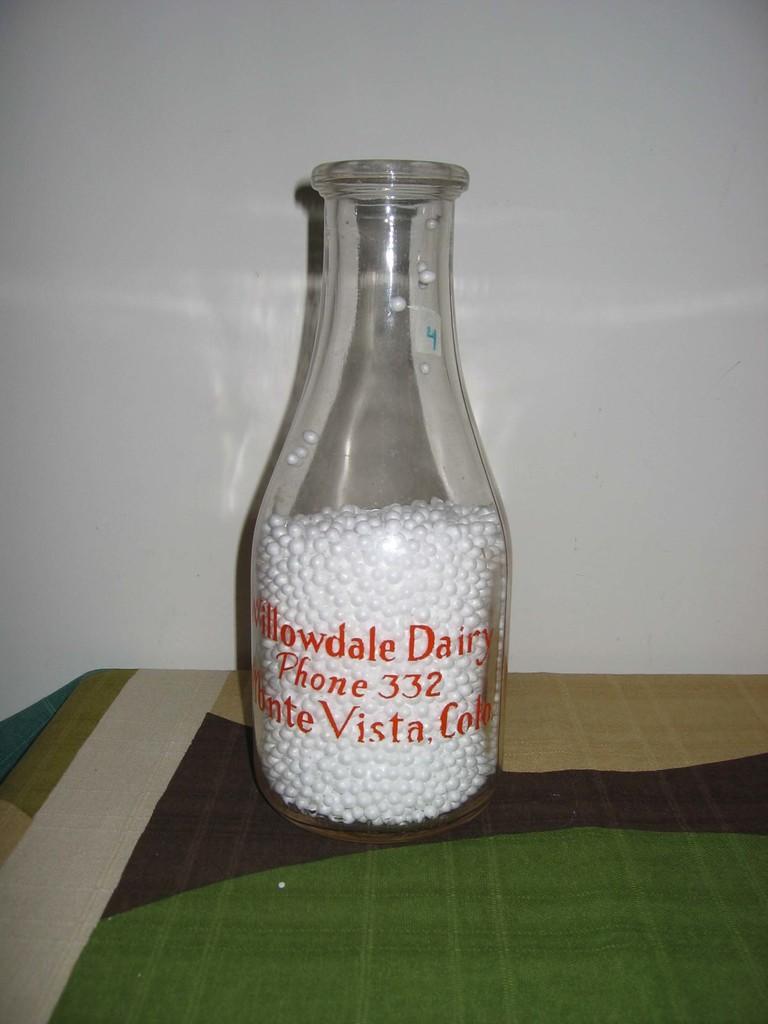What state is the dairy located?
Offer a terse response. Colorado. 